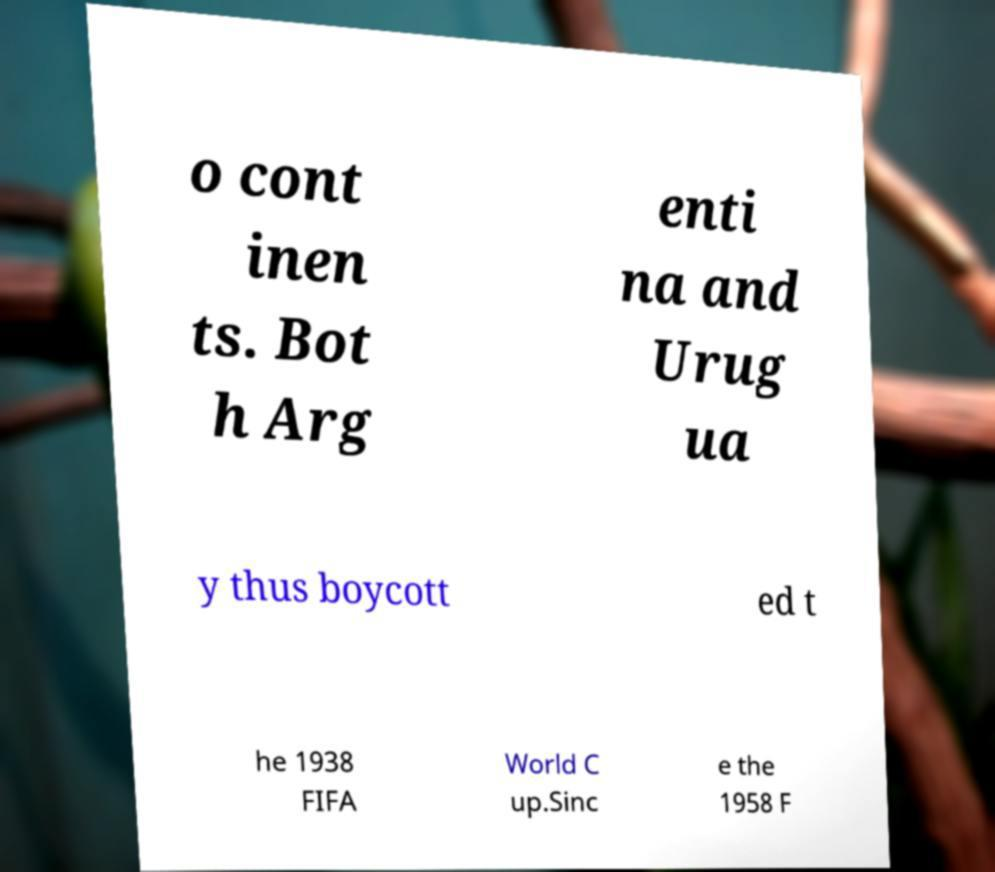I need the written content from this picture converted into text. Can you do that? o cont inen ts. Bot h Arg enti na and Urug ua y thus boycott ed t he 1938 FIFA World C up.Sinc e the 1958 F 